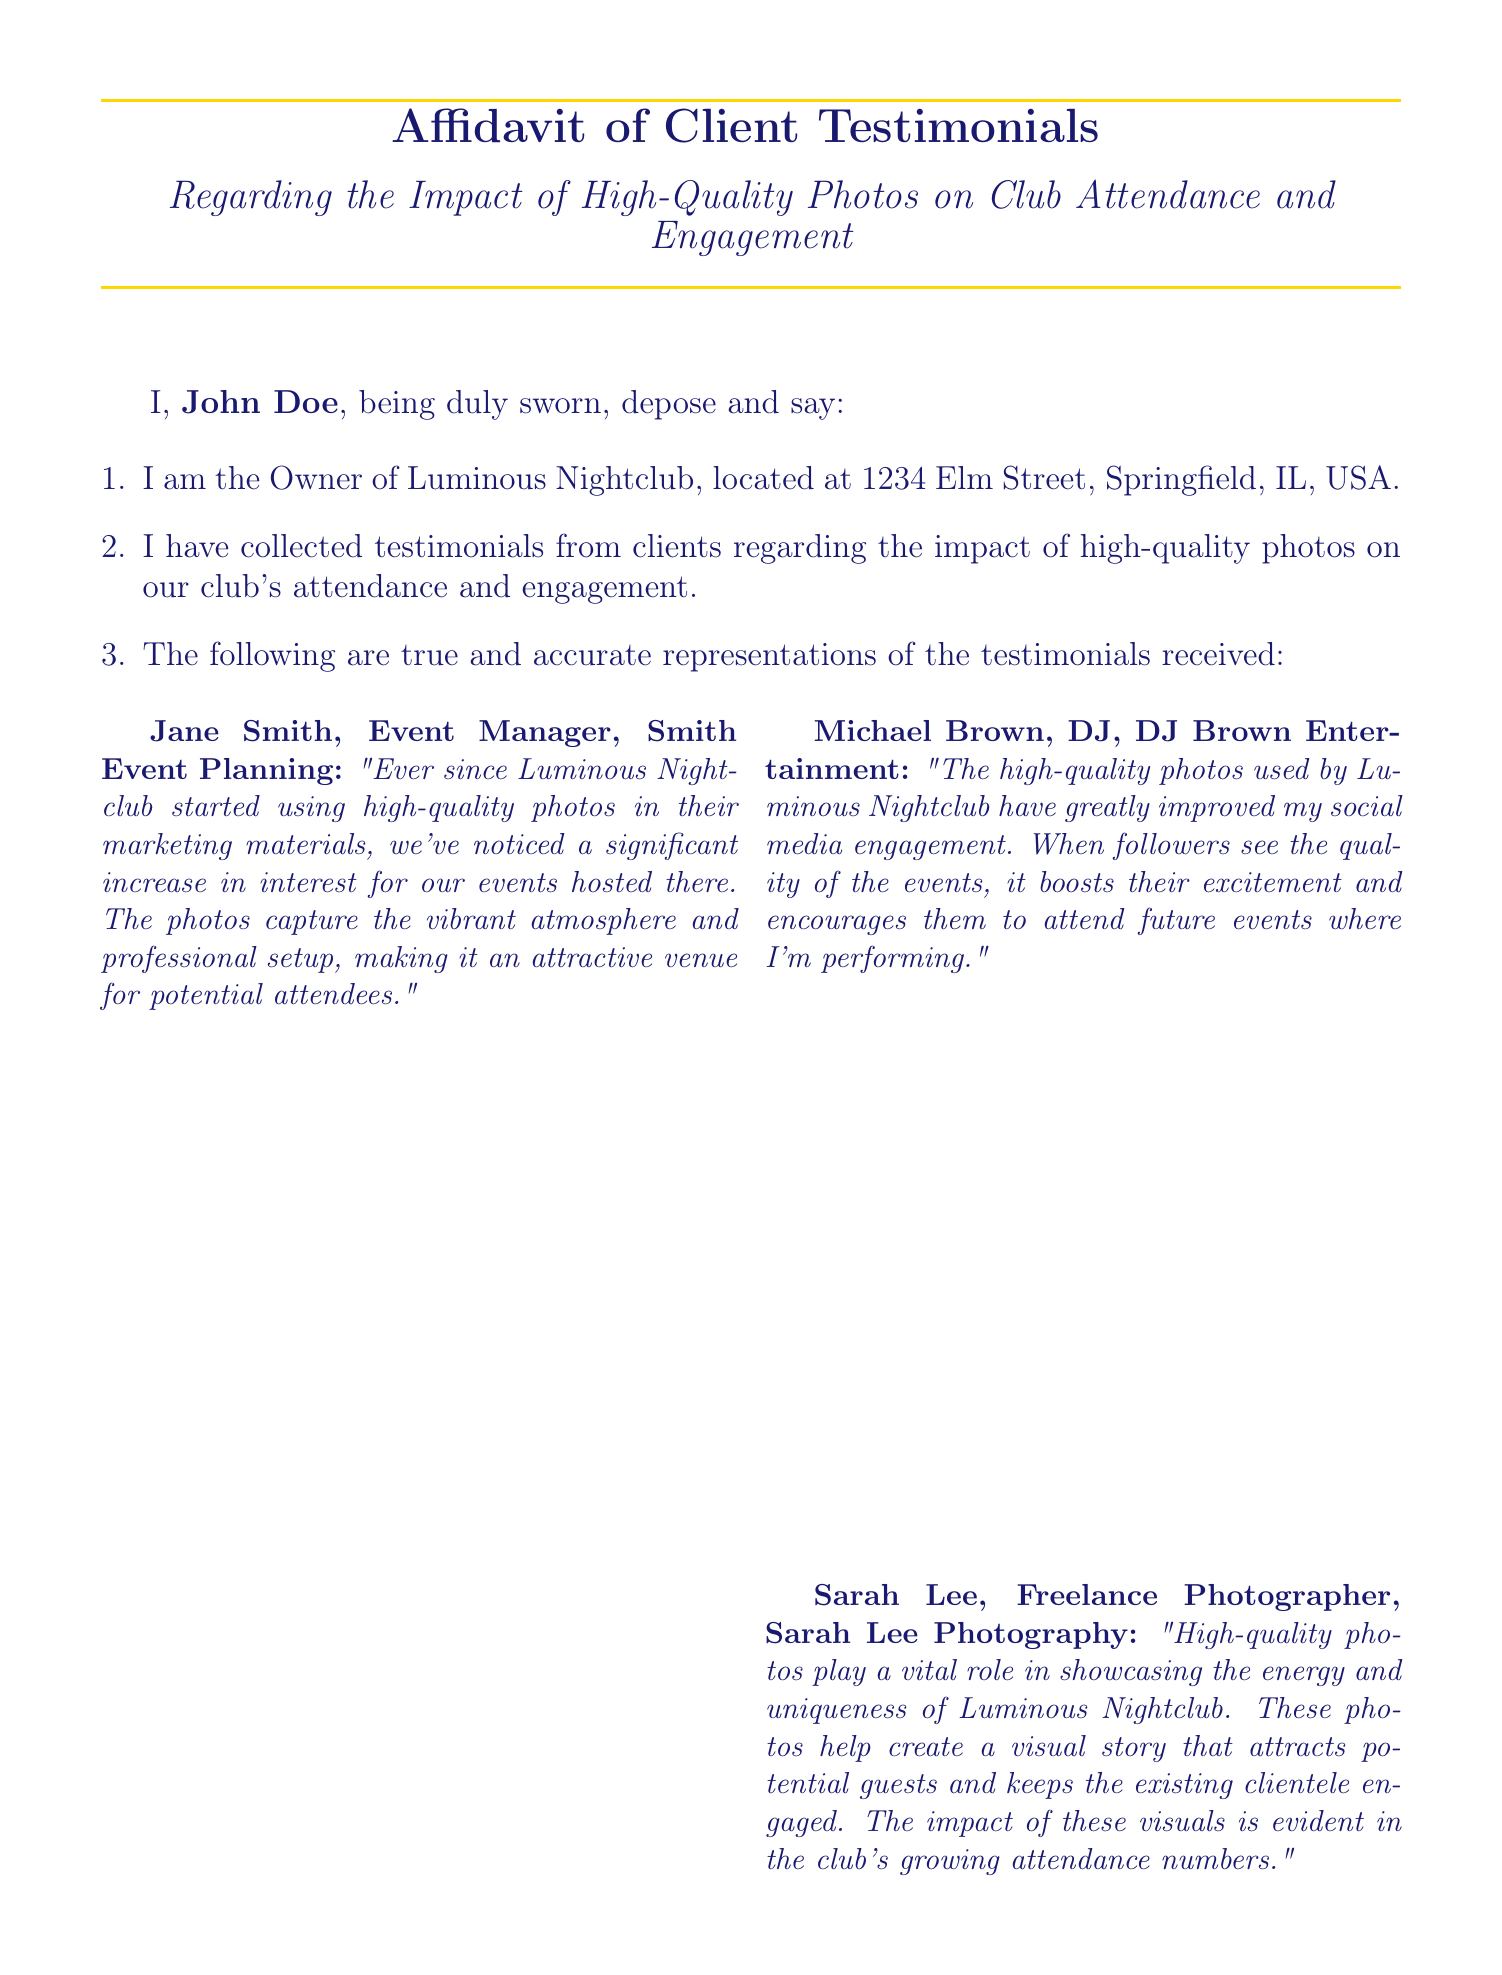What is the name of the club owner? The owner's name, as stated in the affidavit, is John Doe.
Answer: John Doe What is the address of Luminous Nightclub? The affidavit states that Luminous Nightclub is located at 1234 Elm Street, Springfield, IL, USA.
Answer: 1234 Elm Street, Springfield, IL, USA Who provided a testimonial regarding social media engagement? The testimonial about social media engagement was provided by Michael Brown, a DJ.
Answer: Michael Brown How many testimonials are listed in the affidavit? The affidavit includes four testimonials from various individuals.
Answer: Four What impact do high-quality photos have according to the testimonials? According to the testimonials, high-quality photos significantly increase attendance and engagement at the club.
Answer: Increase attendance and engagement What is the role of Sarah Lee in relation to Luminous Nightclub? Sarah Lee is a Freelance Photographer who provided a testimonial about the club.
Answer: Freelance Photographer What effect did high-quality photos have on David Kim's promotional campaigns? David Kim stated that high-quality photos led to a dramatically higher engagement rate in his promotional campaigns.
Answer: Higher engagement rate What does the affiant declare at the end of the affidavit? The affiant declares under penalty of perjury that the information is true and correct.
Answer: True and correct 